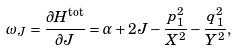Convert formula to latex. <formula><loc_0><loc_0><loc_500><loc_500>\omega _ { J } = \frac { \partial H ^ { \text {tot} } } { \partial J } = \alpha + 2 J - \frac { p _ { 1 } ^ { 2 } } { X ^ { 2 } } - \frac { q _ { 1 } ^ { 2 } } { Y ^ { 2 } } ,</formula> 